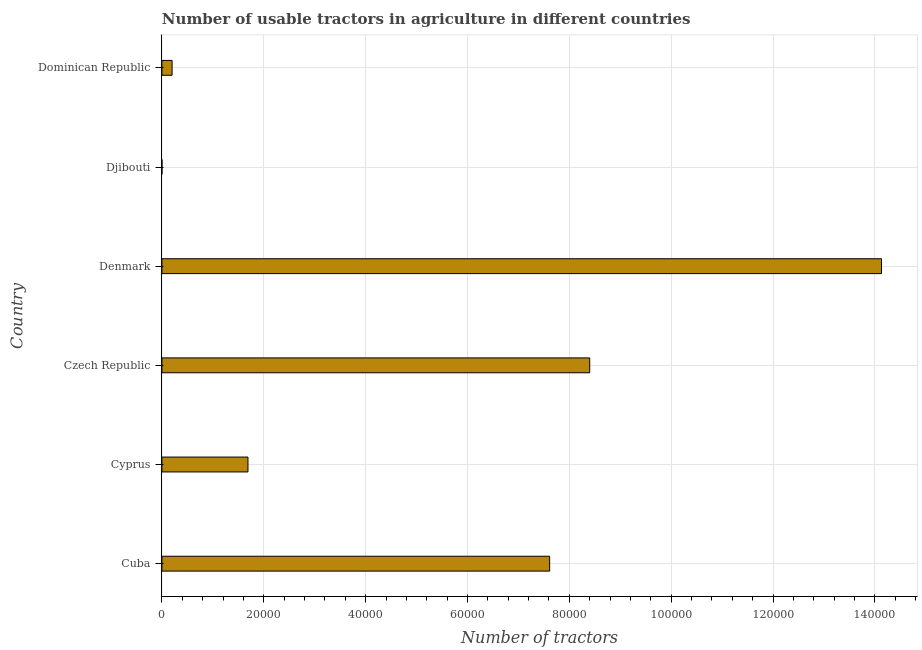Does the graph contain any zero values?
Ensure brevity in your answer.  No. What is the title of the graph?
Make the answer very short. Number of usable tractors in agriculture in different countries. What is the label or title of the X-axis?
Your answer should be compact. Number of tractors. What is the number of tractors in Cyprus?
Give a very brief answer. 1.69e+04. Across all countries, what is the maximum number of tractors?
Your response must be concise. 1.41e+05. In which country was the number of tractors minimum?
Keep it short and to the point. Djibouti. What is the sum of the number of tractors?
Offer a terse response. 3.20e+05. What is the difference between the number of tractors in Denmark and Dominican Republic?
Provide a succinct answer. 1.39e+05. What is the average number of tractors per country?
Ensure brevity in your answer.  5.34e+04. What is the median number of tractors?
Ensure brevity in your answer.  4.65e+04. What is the ratio of the number of tractors in Cuba to that in Czech Republic?
Offer a very short reply. 0.91. What is the difference between the highest and the second highest number of tractors?
Your answer should be very brief. 5.73e+04. What is the difference between the highest and the lowest number of tractors?
Make the answer very short. 1.41e+05. In how many countries, is the number of tractors greater than the average number of tractors taken over all countries?
Your answer should be compact. 3. How many bars are there?
Give a very brief answer. 6. Are all the bars in the graph horizontal?
Ensure brevity in your answer.  Yes. How many countries are there in the graph?
Offer a very short reply. 6. Are the values on the major ticks of X-axis written in scientific E-notation?
Your answer should be very brief. No. What is the Number of tractors of Cuba?
Your answer should be very brief. 7.61e+04. What is the Number of tractors of Cyprus?
Your answer should be compact. 1.69e+04. What is the Number of tractors of Czech Republic?
Provide a succinct answer. 8.40e+04. What is the Number of tractors of Denmark?
Ensure brevity in your answer.  1.41e+05. What is the Number of tractors in Dominican Republic?
Offer a terse response. 2000. What is the difference between the Number of tractors in Cuba and Cyprus?
Give a very brief answer. 5.92e+04. What is the difference between the Number of tractors in Cuba and Czech Republic?
Offer a terse response. -7868. What is the difference between the Number of tractors in Cuba and Denmark?
Ensure brevity in your answer.  -6.52e+04. What is the difference between the Number of tractors in Cuba and Djibouti?
Provide a short and direct response. 7.61e+04. What is the difference between the Number of tractors in Cuba and Dominican Republic?
Provide a short and direct response. 7.41e+04. What is the difference between the Number of tractors in Cyprus and Czech Republic?
Provide a succinct answer. -6.71e+04. What is the difference between the Number of tractors in Cyprus and Denmark?
Make the answer very short. -1.24e+05. What is the difference between the Number of tractors in Cyprus and Djibouti?
Offer a very short reply. 1.69e+04. What is the difference between the Number of tractors in Cyprus and Dominican Republic?
Offer a very short reply. 1.49e+04. What is the difference between the Number of tractors in Czech Republic and Denmark?
Your answer should be very brief. -5.73e+04. What is the difference between the Number of tractors in Czech Republic and Djibouti?
Offer a very short reply. 8.40e+04. What is the difference between the Number of tractors in Czech Republic and Dominican Republic?
Your answer should be compact. 8.20e+04. What is the difference between the Number of tractors in Denmark and Djibouti?
Provide a succinct answer. 1.41e+05. What is the difference between the Number of tractors in Denmark and Dominican Republic?
Make the answer very short. 1.39e+05. What is the difference between the Number of tractors in Djibouti and Dominican Republic?
Provide a succinct answer. -1992. What is the ratio of the Number of tractors in Cuba to that in Cyprus?
Your answer should be compact. 4.5. What is the ratio of the Number of tractors in Cuba to that in Czech Republic?
Offer a very short reply. 0.91. What is the ratio of the Number of tractors in Cuba to that in Denmark?
Ensure brevity in your answer.  0.54. What is the ratio of the Number of tractors in Cuba to that in Djibouti?
Make the answer very short. 9516.5. What is the ratio of the Number of tractors in Cuba to that in Dominican Republic?
Keep it short and to the point. 38.07. What is the ratio of the Number of tractors in Cyprus to that in Czech Republic?
Keep it short and to the point. 0.2. What is the ratio of the Number of tractors in Cyprus to that in Denmark?
Your answer should be very brief. 0.12. What is the ratio of the Number of tractors in Cyprus to that in Djibouti?
Your answer should be very brief. 2112.5. What is the ratio of the Number of tractors in Cyprus to that in Dominican Republic?
Offer a very short reply. 8.45. What is the ratio of the Number of tractors in Czech Republic to that in Denmark?
Offer a terse response. 0.59. What is the ratio of the Number of tractors in Czech Republic to that in Djibouti?
Offer a terse response. 1.05e+04. What is the ratio of the Number of tractors in Czech Republic to that in Dominican Republic?
Your response must be concise. 42. What is the ratio of the Number of tractors in Denmark to that in Djibouti?
Make the answer very short. 1.77e+04. What is the ratio of the Number of tractors in Denmark to that in Dominican Republic?
Your answer should be very brief. 70.65. What is the ratio of the Number of tractors in Djibouti to that in Dominican Republic?
Your answer should be very brief. 0. 